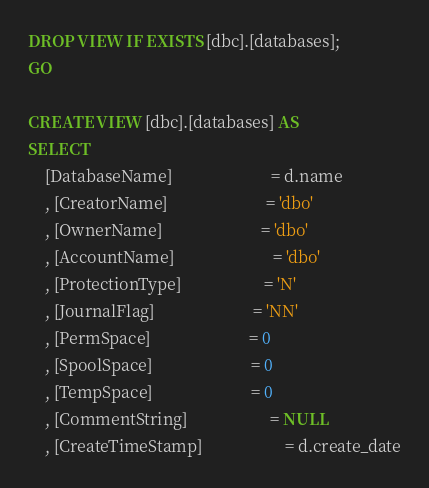Convert code to text. <code><loc_0><loc_0><loc_500><loc_500><_SQL_>DROP VIEW IF EXISTS [dbc].[databases];
GO

CREATE VIEW [dbc].[databases] AS
SELECT
	[DatabaseName]						= d.name
	, [CreatorName]						= 'dbo'
	, [OwnerName]						= 'dbo'
	, [AccountName]						= 'dbo'
	, [ProtectionType]					= 'N'
	, [JournalFlag]						= 'NN'
	, [PermSpace]						= 0
	, [SpoolSpace]						= 0
	, [TempSpace]						= 0
	, [CommentString]					= NULL
	, [CreateTimeStamp]					= d.create_date</code> 